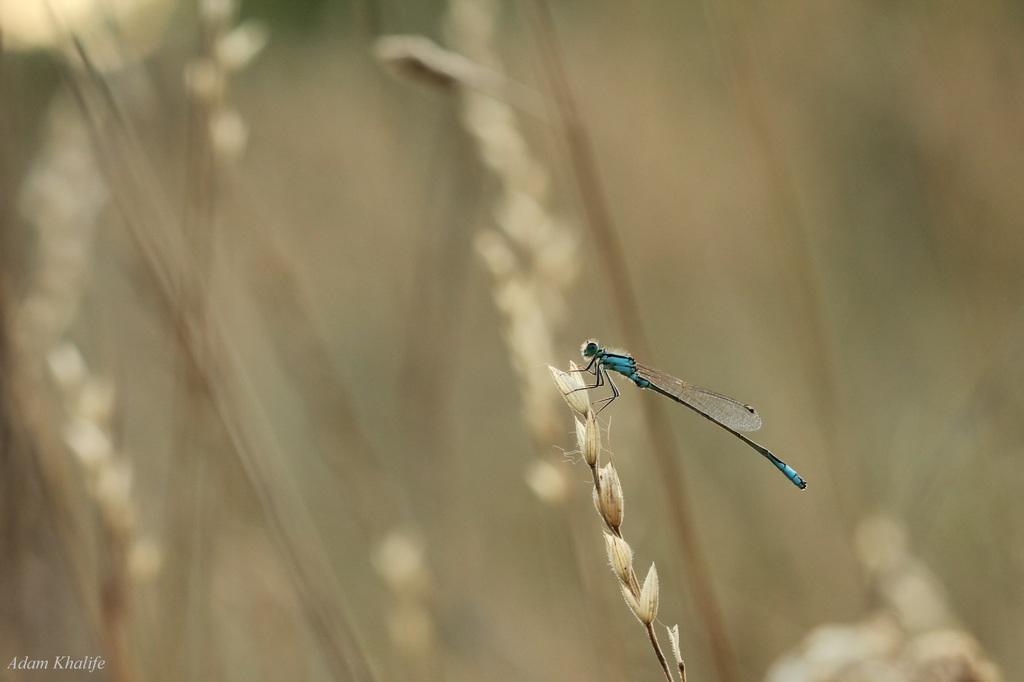Please provide a concise description of this image. In this image in the foreground there is one fly on a plant, and there is blurred background. 